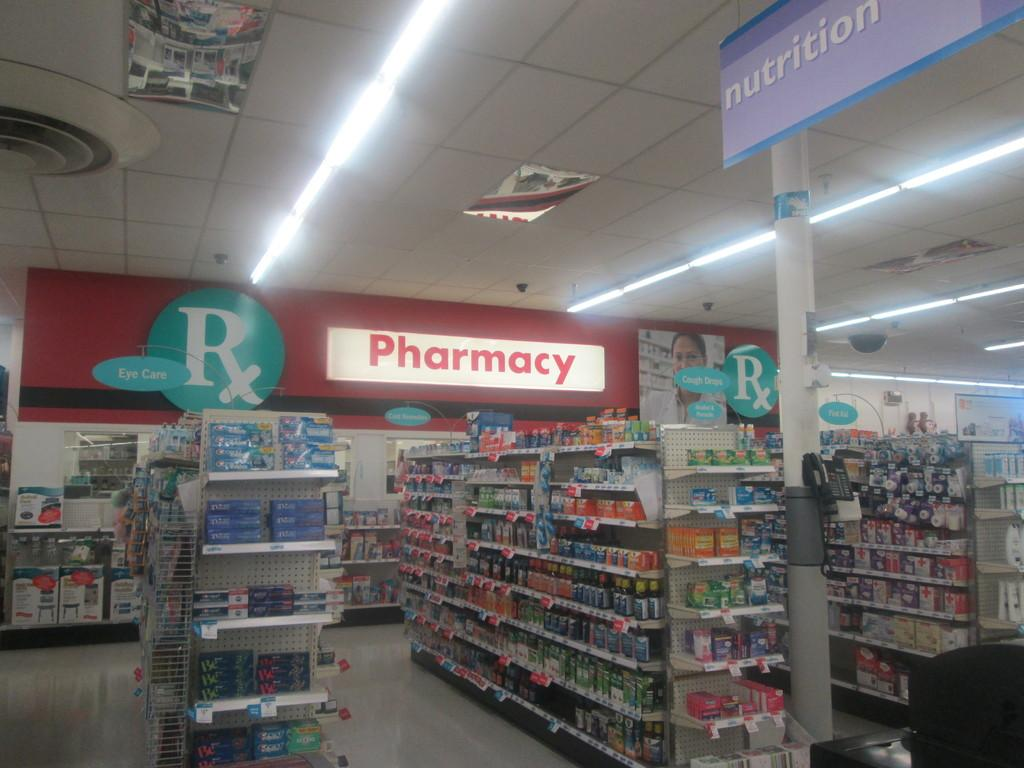<image>
Relay a brief, clear account of the picture shown. Shelves in a store containing Eye Care products sit in front of a large lit up sign that says Pharmacy. 